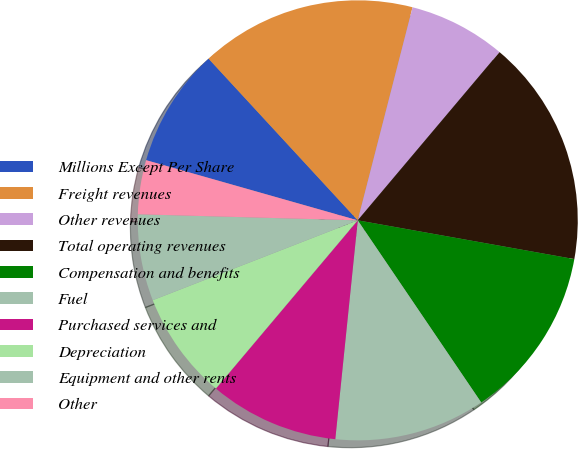<chart> <loc_0><loc_0><loc_500><loc_500><pie_chart><fcel>Millions Except Per Share<fcel>Freight revenues<fcel>Other revenues<fcel>Total operating revenues<fcel>Compensation and benefits<fcel>Fuel<fcel>Purchased services and<fcel>Depreciation<fcel>Equipment and other rents<fcel>Other<nl><fcel>8.73%<fcel>15.87%<fcel>7.14%<fcel>16.67%<fcel>12.7%<fcel>11.11%<fcel>9.52%<fcel>7.94%<fcel>6.35%<fcel>3.97%<nl></chart> 